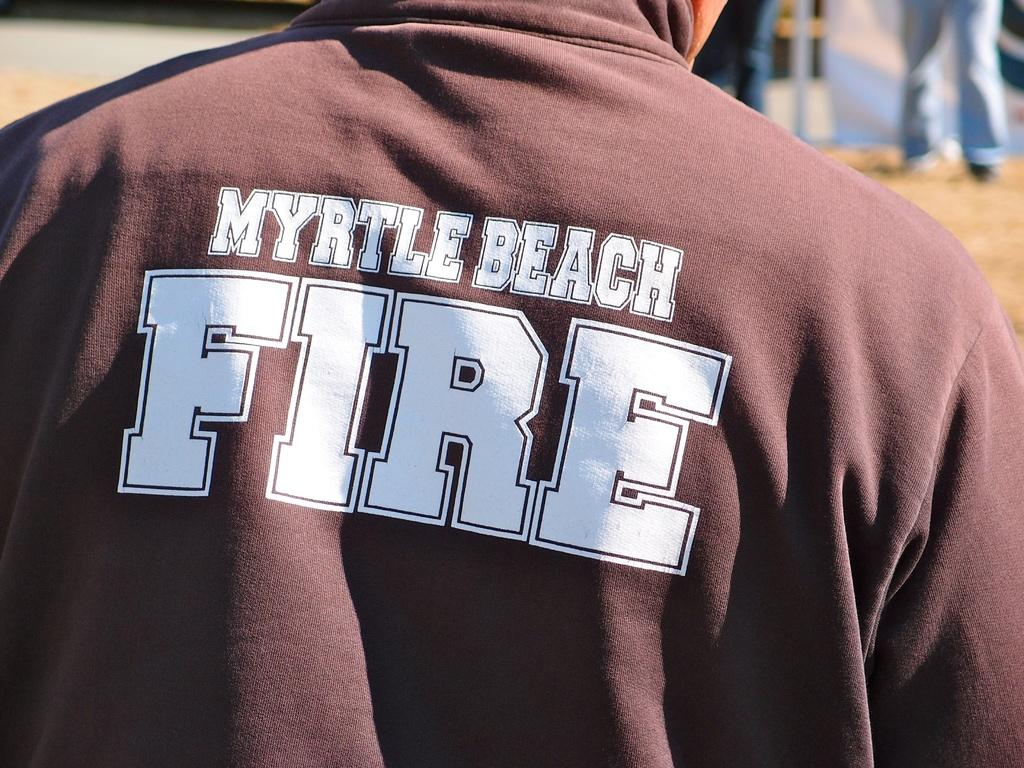Provide a one-sentence caption for the provided image. FIRE is written in big letters on the back of this person's shirt. 